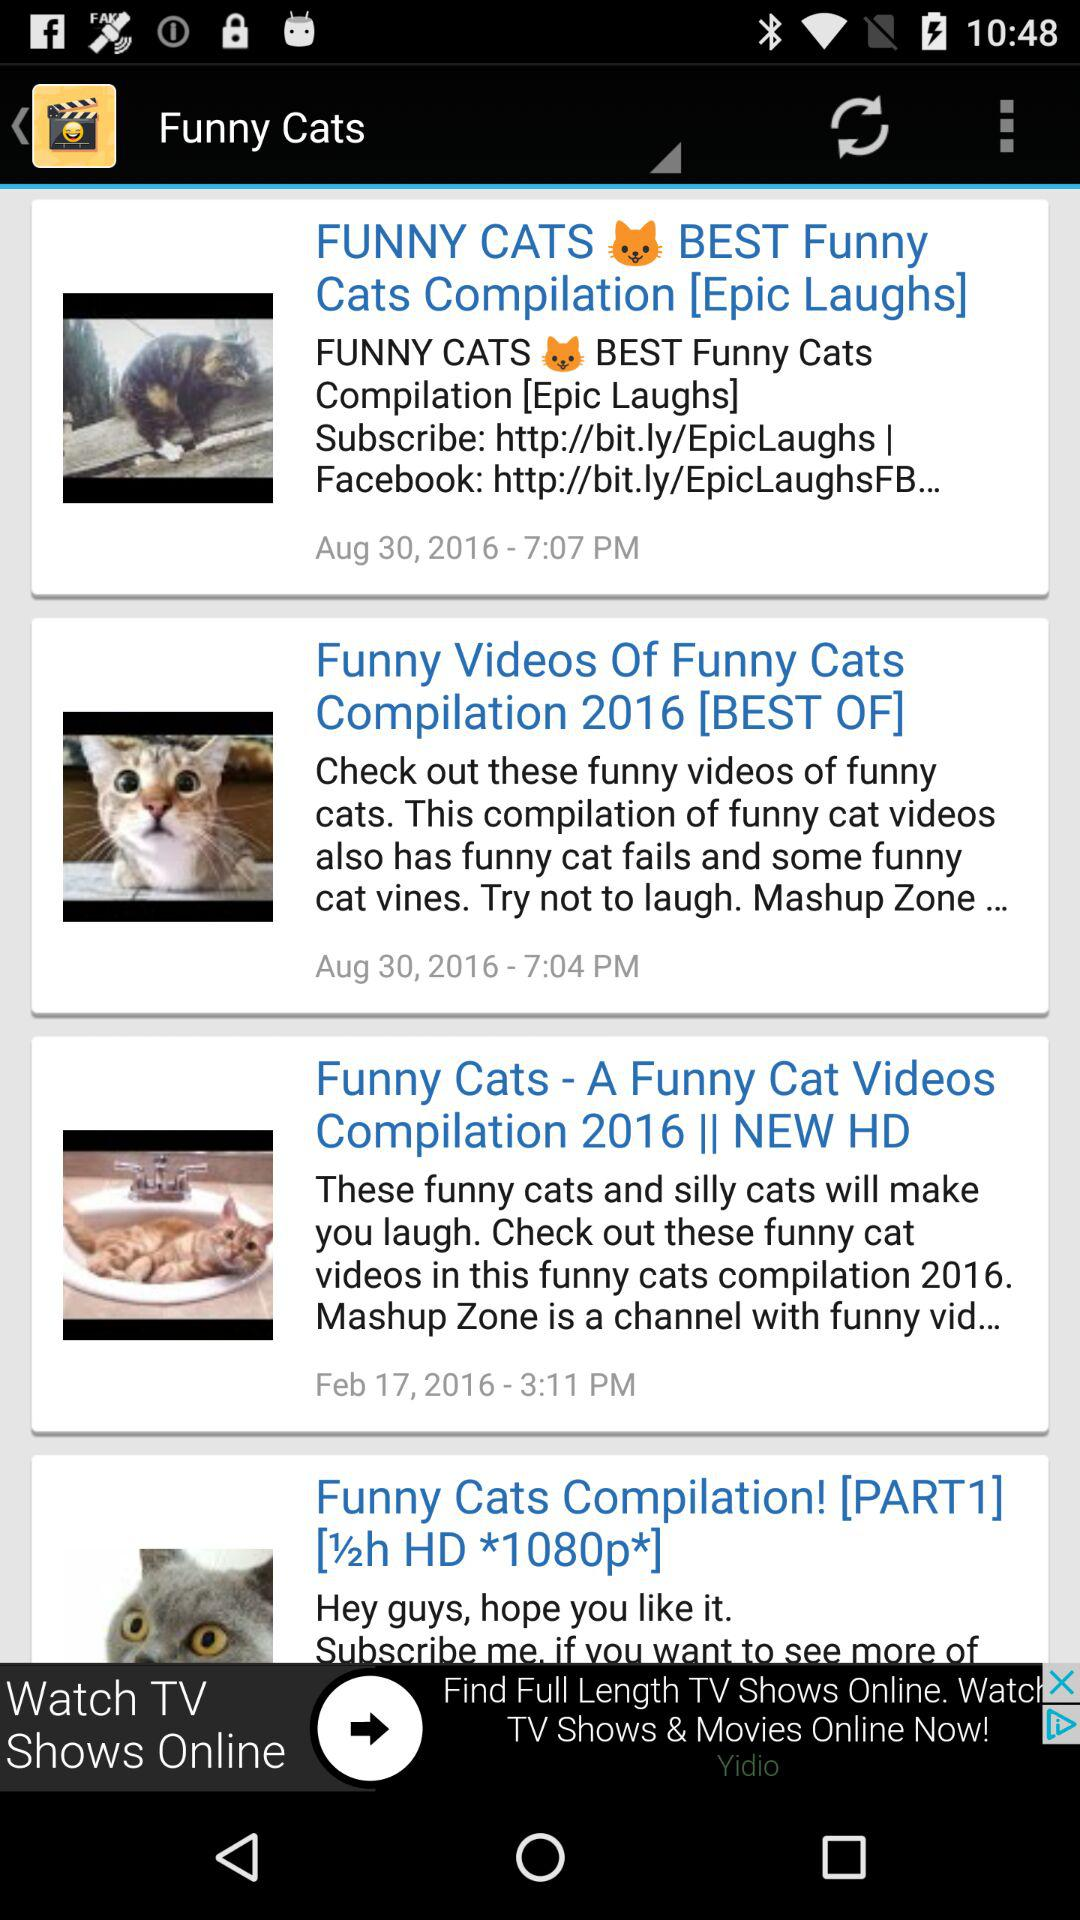What is the posted time of "Funny Cats - A Funny Cat Videos Compilation 2016"? The posted time of "Funny Cats - A Funny Cat Videos Compilation 2016" is 3:11 PM. 